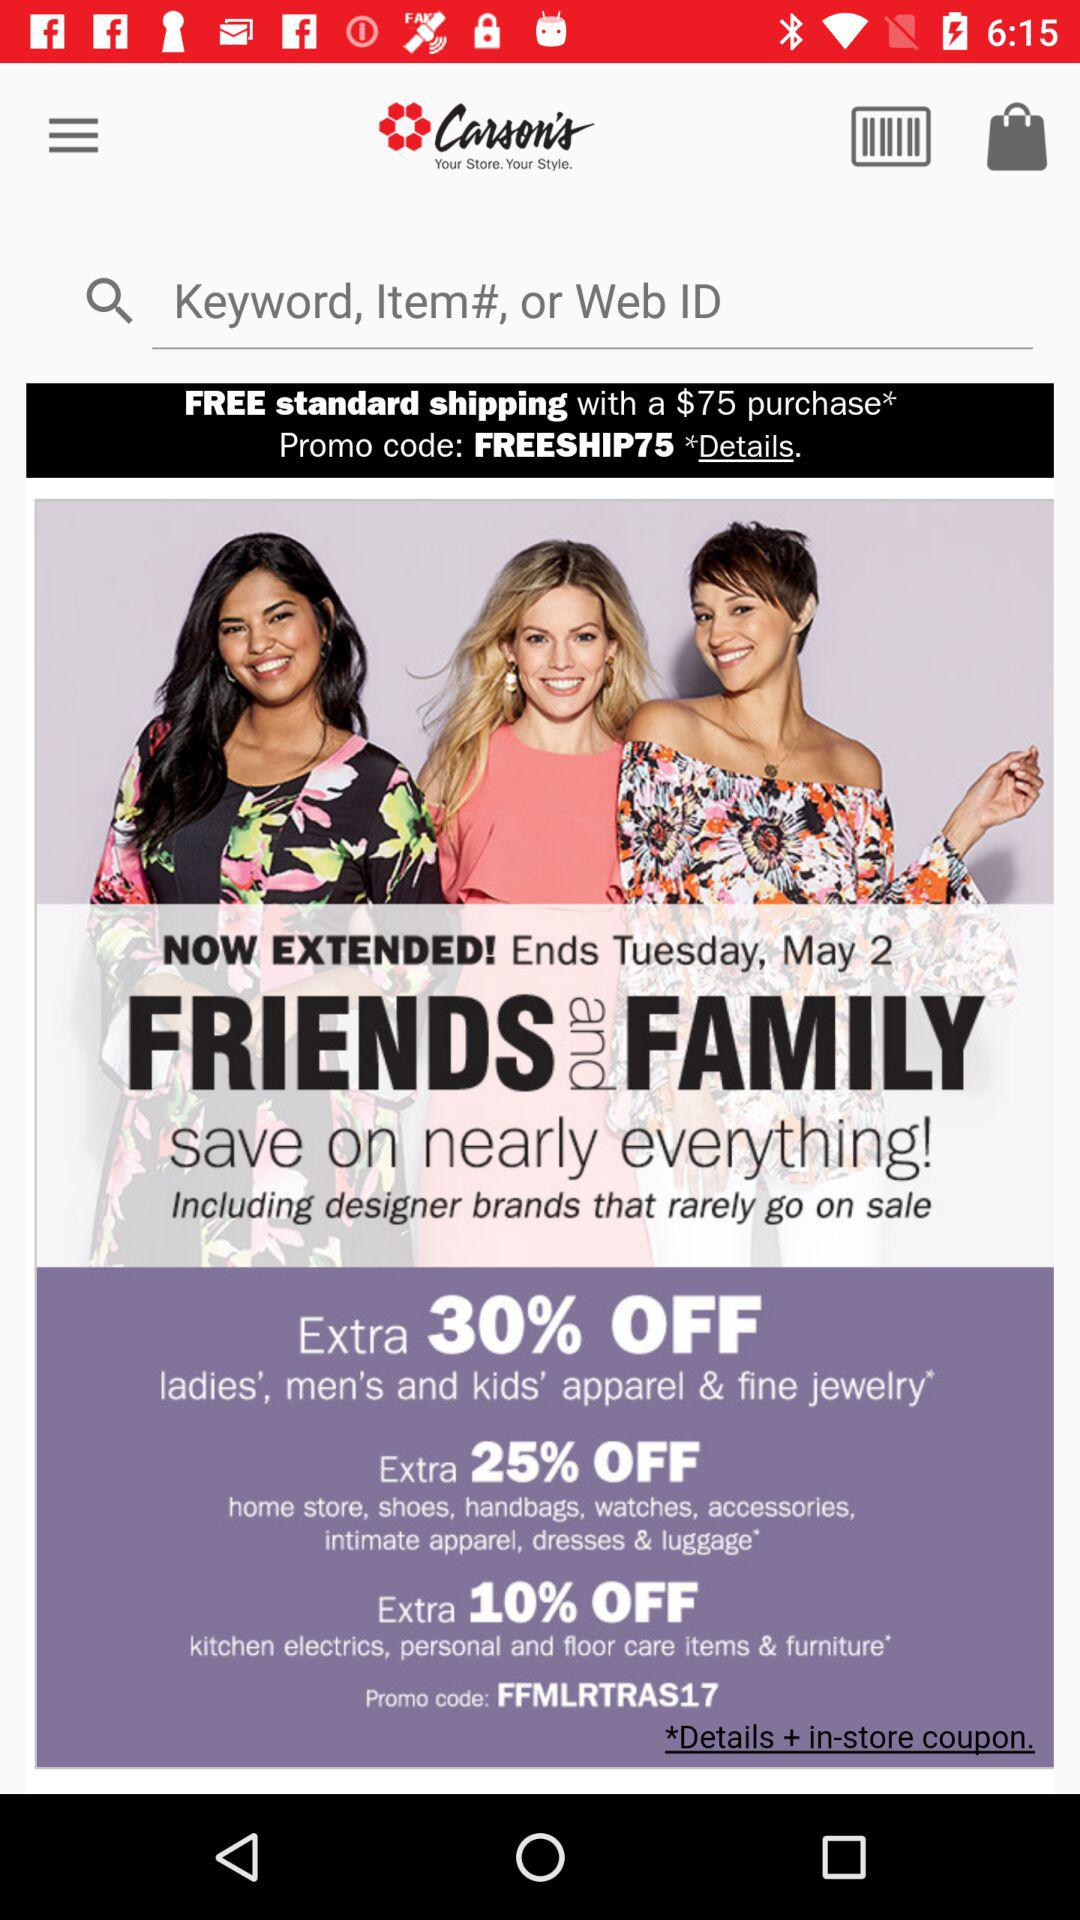How many percent off is the best discount for ladies', men's and kids' apparel & fine jewelry?
Answer the question using a single word or phrase. 30% 